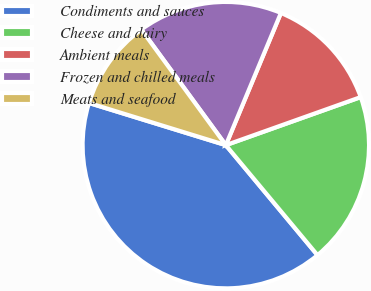Convert chart to OTSL. <chart><loc_0><loc_0><loc_500><loc_500><pie_chart><fcel>Condiments and sauces<fcel>Cheese and dairy<fcel>Ambient meals<fcel>Frozen and chilled meals<fcel>Meats and seafood<nl><fcel>40.82%<fcel>19.39%<fcel>13.27%<fcel>16.33%<fcel>10.2%<nl></chart> 